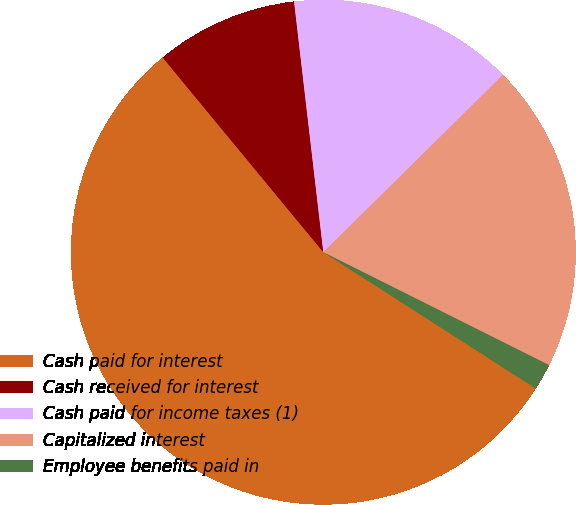Convert chart to OTSL. <chart><loc_0><loc_0><loc_500><loc_500><pie_chart><fcel>Cash paid for interest<fcel>Cash received for interest<fcel>Cash paid for income taxes (1)<fcel>Capitalized interest<fcel>Employee benefits paid in<nl><fcel>54.94%<fcel>9.13%<fcel>14.45%<fcel>19.78%<fcel>1.7%<nl></chart> 